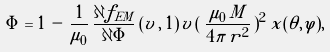<formula> <loc_0><loc_0><loc_500><loc_500>\Phi = 1 \, - \, \frac { 1 } { { \mu } _ { 0 } } \, \frac { \partial f _ { E M } } { \partial \Phi } \, ( v \, , \, 1 ) \, v \, ( \, \frac { { \mu } _ { 0 } \, M } { 4 \pi \, r ^ { 2 } } \, ) ^ { 2 } \, x ( \theta , \varphi ) ,</formula> 